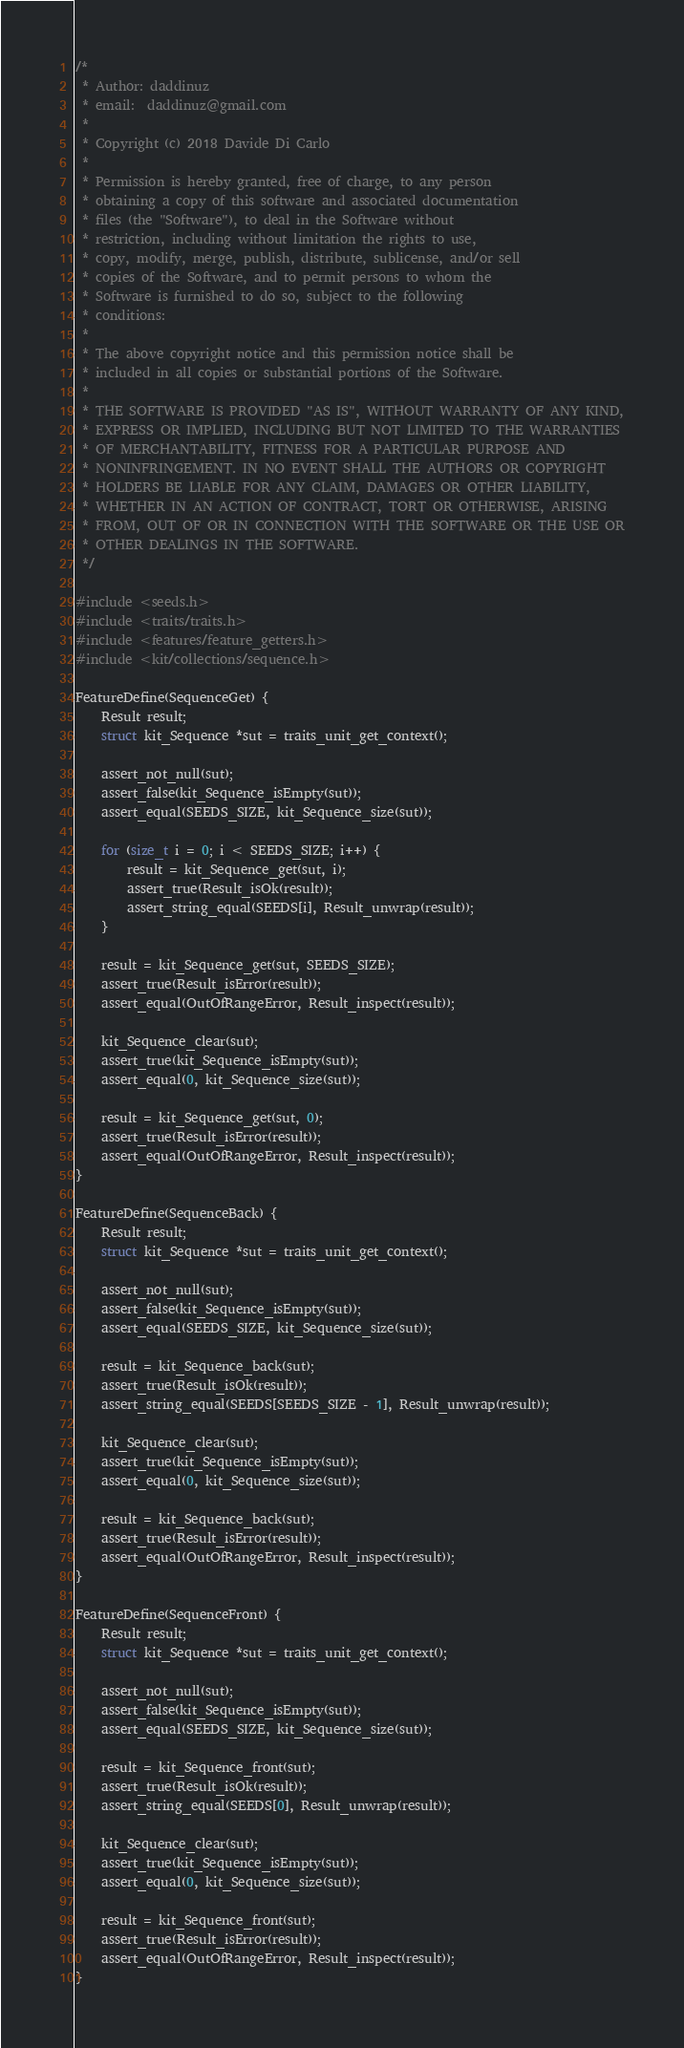Convert code to text. <code><loc_0><loc_0><loc_500><loc_500><_C_>/*
 * Author: daddinuz
 * email:  daddinuz@gmail.com
 *
 * Copyright (c) 2018 Davide Di Carlo
 *
 * Permission is hereby granted, free of charge, to any person
 * obtaining a copy of this software and associated documentation
 * files (the "Software"), to deal in the Software without
 * restriction, including without limitation the rights to use,
 * copy, modify, merge, publish, distribute, sublicense, and/or sell
 * copies of the Software, and to permit persons to whom the
 * Software is furnished to do so, subject to the following
 * conditions:
 *
 * The above copyright notice and this permission notice shall be
 * included in all copies or substantial portions of the Software.
 *
 * THE SOFTWARE IS PROVIDED "AS IS", WITHOUT WARRANTY OF ANY KIND,
 * EXPRESS OR IMPLIED, INCLUDING BUT NOT LIMITED TO THE WARRANTIES
 * OF MERCHANTABILITY, FITNESS FOR A PARTICULAR PURPOSE AND
 * NONINFRINGEMENT. IN NO EVENT SHALL THE AUTHORS OR COPYRIGHT
 * HOLDERS BE LIABLE FOR ANY CLAIM, DAMAGES OR OTHER LIABILITY,
 * WHETHER IN AN ACTION OF CONTRACT, TORT OR OTHERWISE, ARISING
 * FROM, OUT OF OR IN CONNECTION WITH THE SOFTWARE OR THE USE OR
 * OTHER DEALINGS IN THE SOFTWARE.
 */

#include <seeds.h>
#include <traits/traits.h>
#include <features/feature_getters.h>
#include <kit/collections/sequence.h>

FeatureDefine(SequenceGet) {
    Result result;
    struct kit_Sequence *sut = traits_unit_get_context();

    assert_not_null(sut);
    assert_false(kit_Sequence_isEmpty(sut));
    assert_equal(SEEDS_SIZE, kit_Sequence_size(sut));

    for (size_t i = 0; i < SEEDS_SIZE; i++) {
        result = kit_Sequence_get(sut, i);
        assert_true(Result_isOk(result));
        assert_string_equal(SEEDS[i], Result_unwrap(result));
    }

    result = kit_Sequence_get(sut, SEEDS_SIZE);
    assert_true(Result_isError(result));
    assert_equal(OutOfRangeError, Result_inspect(result));

    kit_Sequence_clear(sut);
    assert_true(kit_Sequence_isEmpty(sut));
    assert_equal(0, kit_Sequence_size(sut));

    result = kit_Sequence_get(sut, 0);
    assert_true(Result_isError(result));
    assert_equal(OutOfRangeError, Result_inspect(result));
}

FeatureDefine(SequenceBack) {
    Result result;
    struct kit_Sequence *sut = traits_unit_get_context();

    assert_not_null(sut);
    assert_false(kit_Sequence_isEmpty(sut));
    assert_equal(SEEDS_SIZE, kit_Sequence_size(sut));

    result = kit_Sequence_back(sut);
    assert_true(Result_isOk(result));
    assert_string_equal(SEEDS[SEEDS_SIZE - 1], Result_unwrap(result));

    kit_Sequence_clear(sut);
    assert_true(kit_Sequence_isEmpty(sut));
    assert_equal(0, kit_Sequence_size(sut));

    result = kit_Sequence_back(sut);
    assert_true(Result_isError(result));
    assert_equal(OutOfRangeError, Result_inspect(result));
}

FeatureDefine(SequenceFront) {
    Result result;
    struct kit_Sequence *sut = traits_unit_get_context();

    assert_not_null(sut);
    assert_false(kit_Sequence_isEmpty(sut));
    assert_equal(SEEDS_SIZE, kit_Sequence_size(sut));

    result = kit_Sequence_front(sut);
    assert_true(Result_isOk(result));
    assert_string_equal(SEEDS[0], Result_unwrap(result));

    kit_Sequence_clear(sut);
    assert_true(kit_Sequence_isEmpty(sut));
    assert_equal(0, kit_Sequence_size(sut));

    result = kit_Sequence_front(sut);
    assert_true(Result_isError(result));
    assert_equal(OutOfRangeError, Result_inspect(result));
}
</code> 